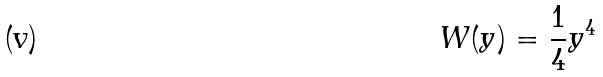<formula> <loc_0><loc_0><loc_500><loc_500>W ( y ) = \frac { 1 } { 4 } y ^ { 4 }</formula> 